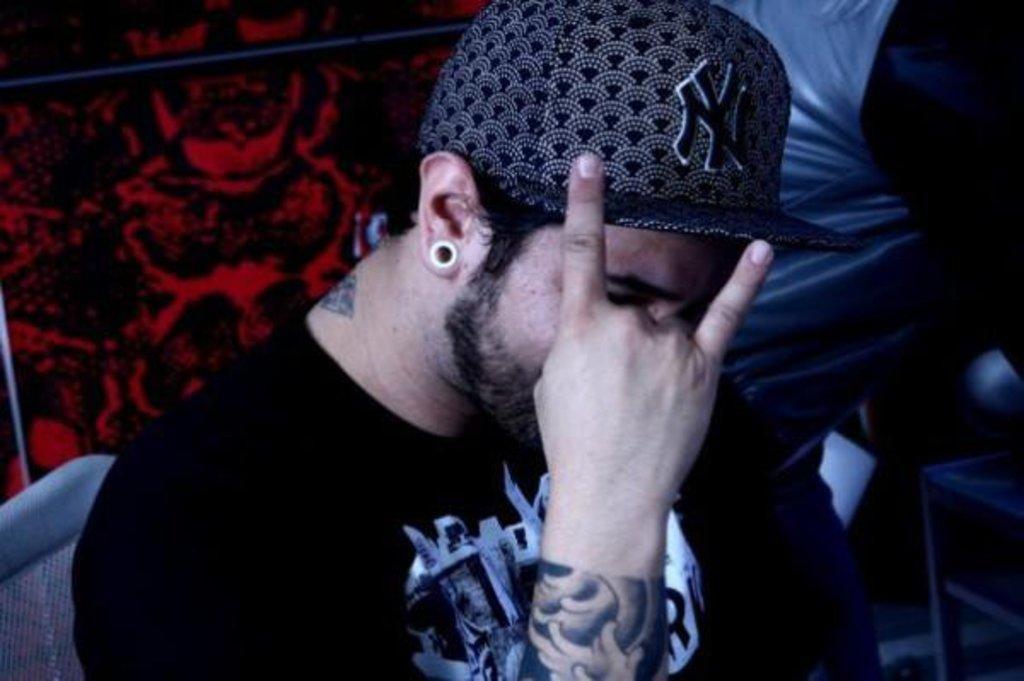How would you summarize this image in a sentence or two? In this image there is a man towards the bottom of the image, he is wearing a T-shirt, he is wearing a cap, there is a chair towards the left of the image, there is an object towards the left of the image, there are objects towards the right of the image, there is an object towards the top of the image, at the background of the image there is an object, the object is black and red in color. 